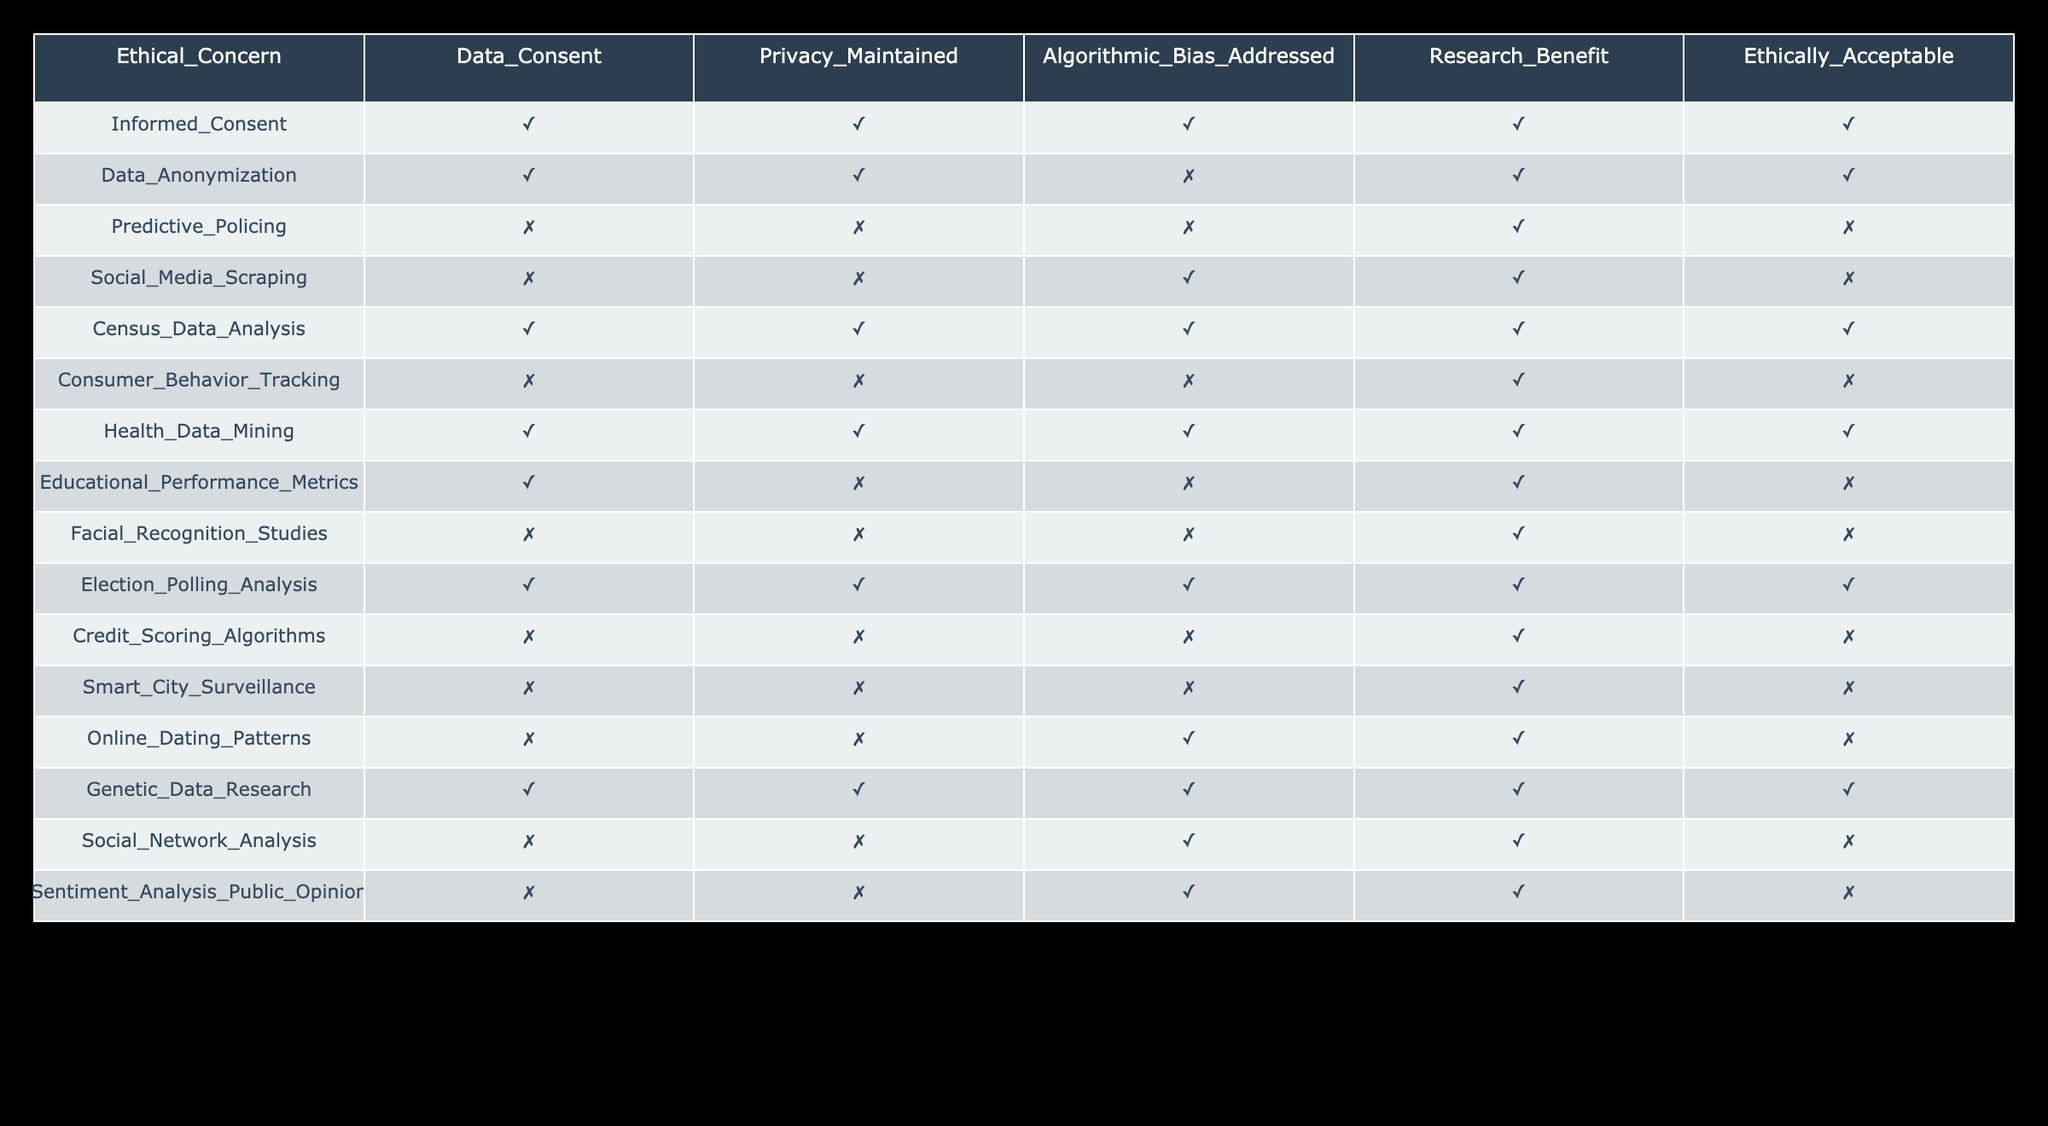What ethical concern has the highest number of "Ethically Acceptable" cases? By examining the "Ethically Acceptable" column, we see that "Informed Consent," "Data Anonymization," "Census Data Analysis," "Health Data Mining," and "Election Polling Analysis" are marked as acceptable. It counts five cases, so the highest number of ethically acceptable cases is five, equating to several ethical concerns.
Answer: There are five cases How many research areas found to be ethically acceptable do not address algorithmic bias? Looking at the table, we count "Data Anonymization," "Census Data Analysis," "Health Data Mining," and "Election Polling Analysis." Out of these, "Data Anonymization," "Census Data Analysis," "Health Data Mining," and "Election Polling Analysis" are the areas that do not address algorithmic bias; thus, there are four areas where ethical acceptance is upheld without addressing algorithmic bias.
Answer: Four areas Is "Predictive Policing" ethically acceptable? In the table, "Predictive Policing" is marked as "False" in the "Ethically Acceptable" column, indicating that it is not considered ethically acceptable.
Answer: No What is the total count of research areas where data consent is not obtained but are still deemed beneficial? Checking the table, "Predictive Policing," "Social Media Scraping," "Consumer Behavior Tracking," "Facial Recognition Studies," "Smart City Surveillance," "Online Dating Patterns," "Sentiment Analysis Public Opinion" are the ones without data consent but are marked beneficial (TRUE). We count these areas and find there are seven instances.
Answer: Seven areas How many research areas show that privacy is maintained while being ethically acceptable? From the table, the areas where privacy is maintained ("TRUE") and are ethically acceptable are "Informed Consent," "Data Anonymization," "Census Data Analysis," "Health Data Mining," and "Election Polling Analysis." That totals five areas which maintain privacy while also being ethically acceptable.
Answer: Five areas 